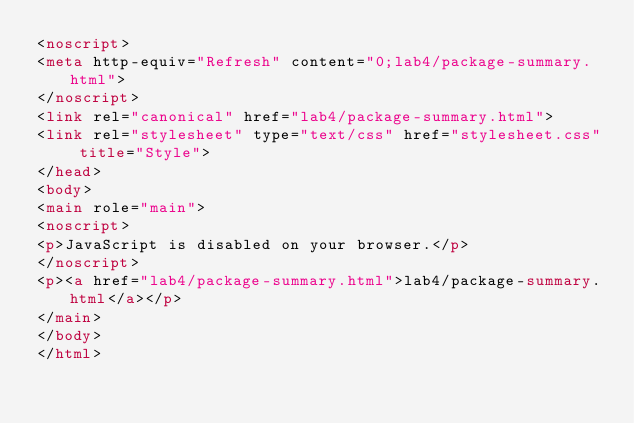<code> <loc_0><loc_0><loc_500><loc_500><_HTML_><noscript>
<meta http-equiv="Refresh" content="0;lab4/package-summary.html">
</noscript>
<link rel="canonical" href="lab4/package-summary.html">
<link rel="stylesheet" type="text/css" href="stylesheet.css" title="Style">
</head>
<body>
<main role="main">
<noscript>
<p>JavaScript is disabled on your browser.</p>
</noscript>
<p><a href="lab4/package-summary.html">lab4/package-summary.html</a></p>
</main>
</body>
</html>
</code> 